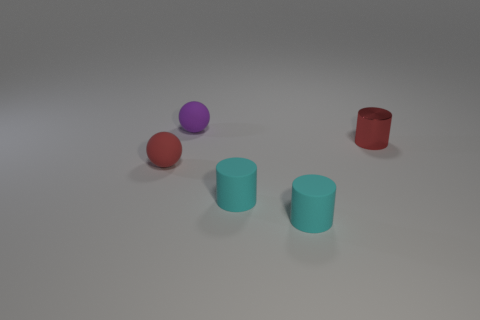Subtract all brown cylinders. Subtract all green blocks. How many cylinders are left? 3 Add 1 small red cylinders. How many objects exist? 6 Subtract all balls. How many objects are left? 3 Subtract 0 cyan cubes. How many objects are left? 5 Subtract all small red matte things. Subtract all tiny red objects. How many objects are left? 2 Add 5 shiny cylinders. How many shiny cylinders are left? 6 Add 4 cubes. How many cubes exist? 4 